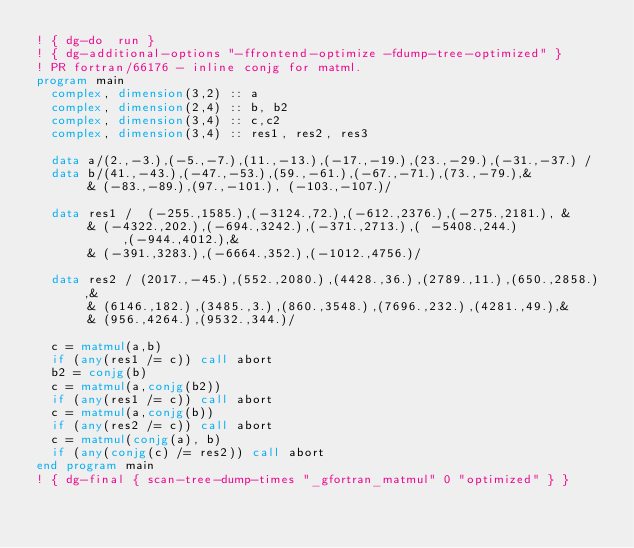Convert code to text. <code><loc_0><loc_0><loc_500><loc_500><_FORTRAN_>! { dg-do  run }
! { dg-additional-options "-ffrontend-optimize -fdump-tree-optimized" }
! PR fortran/66176 - inline conjg for matml.
program main
  complex, dimension(3,2) :: a
  complex, dimension(2,4) :: b, b2
  complex, dimension(3,4) :: c,c2
  complex, dimension(3,4) :: res1, res2, res3

  data a/(2.,-3.),(-5.,-7.),(11.,-13.),(-17.,-19.),(23.,-29.),(-31.,-37.) /
  data b/(41.,-43.),(-47.,-53.),(59.,-61.),(-67.,-71.),(73.,-79.),&
       & (-83.,-89.),(97.,-101.), (-103.,-107.)/

  data res1 /  (-255.,1585.),(-3124.,72.),(-612.,2376.),(-275.,2181.), &
       & (-4322.,202.),(-694.,3242.),(-371.,2713.),( -5408.,244.),(-944.,4012.),&
       & (-391.,3283.),(-6664.,352.),(-1012.,4756.)/

  data res2 / (2017.,-45.),(552.,2080.),(4428.,36.),(2789.,11.),(650.,2858.),&
       & (6146.,182.),(3485.,3.),(860.,3548.),(7696.,232.),(4281.,49.),&
       & (956.,4264.),(9532.,344.)/

  c = matmul(a,b)
  if (any(res1 /= c)) call abort
  b2 = conjg(b)
  c = matmul(a,conjg(b2))
  if (any(res1 /= c)) call abort
  c = matmul(a,conjg(b))
  if (any(res2 /= c)) call abort
  c = matmul(conjg(a), b)
  if (any(conjg(c) /= res2)) call abort
end program main
! { dg-final { scan-tree-dump-times "_gfortran_matmul" 0 "optimized" } }
</code> 